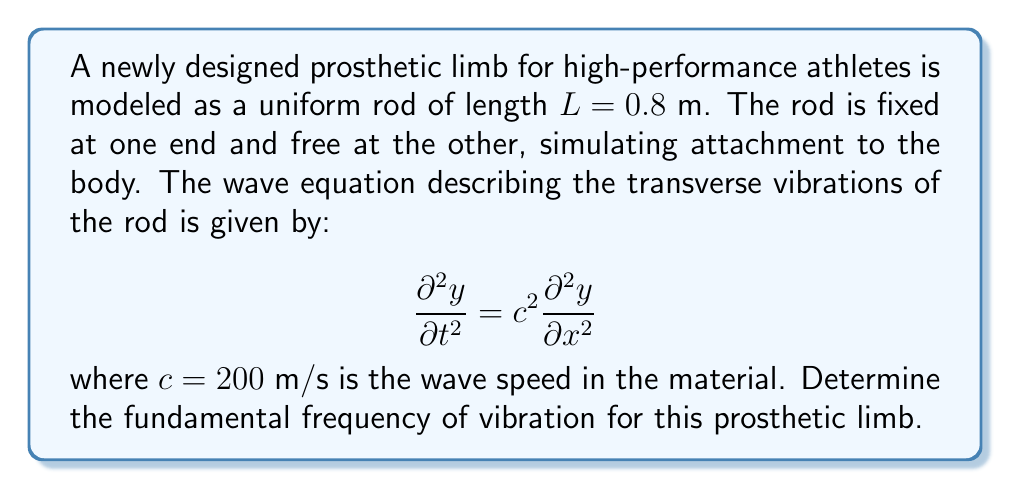Show me your answer to this math problem. To solve this problem, we'll follow these steps:

1) For a rod fixed at one end and free at the other, the boundary conditions are:
   $y(0,t) = 0$ (fixed end)
   $\frac{\partial y}{\partial x}(L,t) = 0$ (free end)

2) The general solution for the wave equation with these boundary conditions is:
   $$y(x,t) = \sum_{n=1}^{\infty} A_n \sin\left(\frac{(2n-1)\pi x}{2L}\right)\cos\left(\frac{(2n-1)\pi c t}{2L}\right)$$

3) The fundamental frequency corresponds to $n=1$. The angular frequency $\omega$ for this mode is:
   $$\omega = \frac{\pi c}{2L}$$

4) To convert angular frequency to regular frequency $f$, we use:
   $$f = \frac{\omega}{2\pi}$$

5) Substituting the given values:
   $$f = \frac{\pi c}{4\pi L} = \frac{c}{4L} = \frac{200}{4(0.8)} = 62.5\text{ Hz}$$

Therefore, the fundamental frequency of vibration for this prosthetic limb is 62.5 Hz.
Answer: 62.5 Hz 